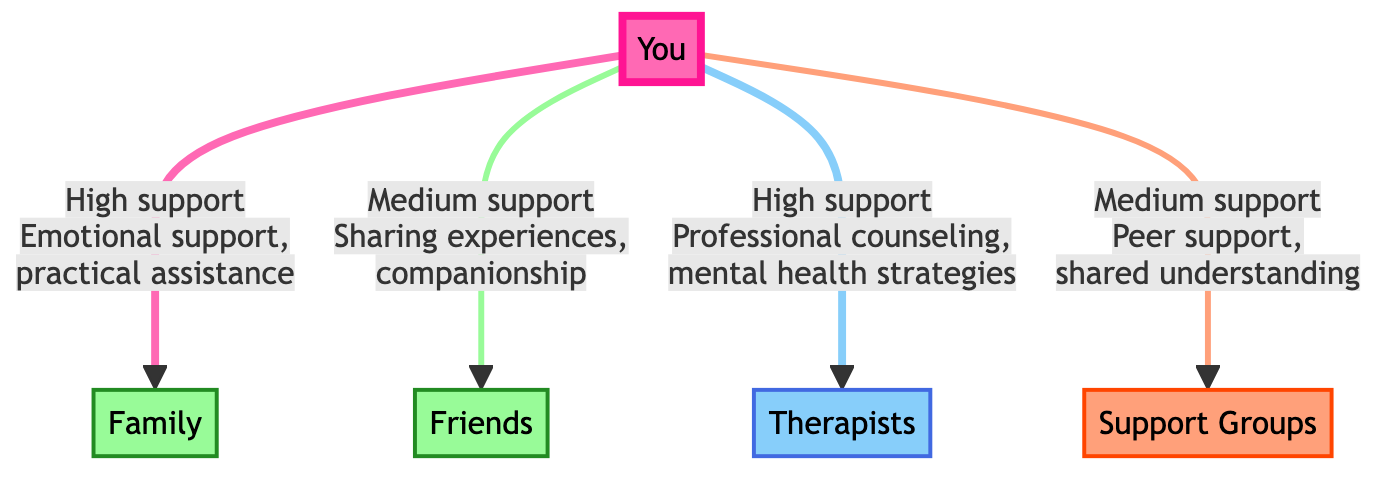What is the central node in the diagram? The central node is represented by "You," which connects to all other nodes in the diagram. This is the focal point of the support network.
Answer: You How many support groups are identified in the network? There are three support groups identified: Family, Friends, and Support Groups, as specified in the nodes section.
Answer: 3 What type of support do Therapists provide? The role of Therapists is professional counseling and mental health strategies. This is specified in the relationship details between "You" and "Therapists."
Answer: Professional counseling, mental health strategies Which node provides high-level support according to the diagram? The nodes that provide high-level support are Family and Therapists, as indicated by the support level description connected to both nodes.
Answer: Family, Therapists What is the relationship between "You" and Friends? The relationship indicated is friends_support, describing the link to Friends with a medium level of support, which includes sharing experiences and companionship.
Answer: friends_support What is the role of Support Groups in your emotional recovery? Support Groups provide peer support and shared understanding, facilitating a sense of community for individuals during their emotional recovery process.
Answer: Peer support, shared understanding Which has a higher level of support, Family or Friends? Family has a high level of support while Friends only provides medium level support according to the edges linking those nodes to "You."
Answer: Family How many edges are there in the diagram? The number of edges is four, with each edge representing the support relationships between "You" and the other nodes in the network.
Answer: 4 What type of support do Friends provide? Friends provide companionship and sharing experiences, contributing to the emotional recovery process. This is detailed in the relationship link from "You" to Friends.
Answer: Sharing experiences, companionship 